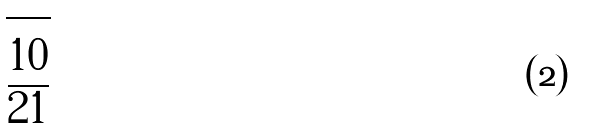<formula> <loc_0><loc_0><loc_500><loc_500>\sqrt { \frac { 1 0 } { 2 1 } }</formula> 